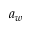<formula> <loc_0><loc_0><loc_500><loc_500>a _ { w }</formula> 